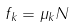<formula> <loc_0><loc_0><loc_500><loc_500>f _ { k } = \mu _ { k } N</formula> 